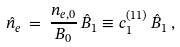Convert formula to latex. <formula><loc_0><loc_0><loc_500><loc_500>\hat { n } _ { e } \, = \, \frac { n _ { e , 0 } } { B _ { 0 } } \, \hat { B } _ { 1 } \equiv c ^ { ( 1 1 ) } _ { 1 } \, \hat { B } _ { 1 } \, ,</formula> 